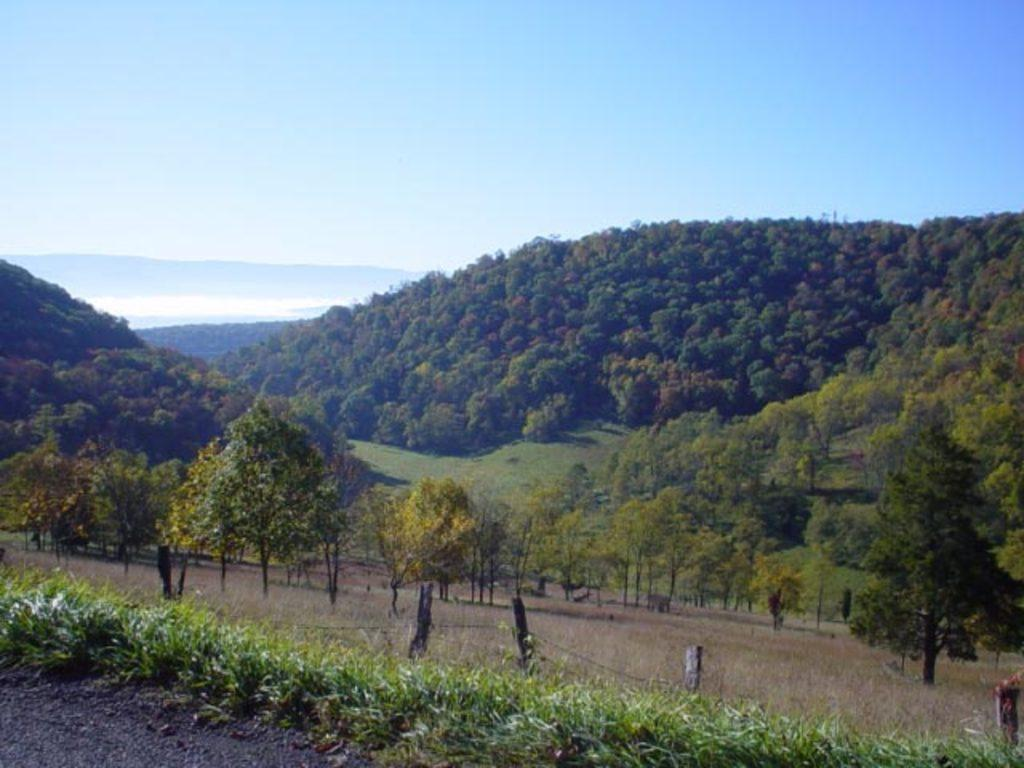What type of vegetation can be seen in the image? There are trees, plants, and grass visible in the image. What type of landscape feature is present in the image? There are hills in the image. What type of barrier can be seen in the image? There is fencing in the image. What part of the natural environment is visible in the image? The sky is visible in the image. How many brothers are depicted in the image? There are no brothers present in the image; it features trees, hills, plants, grass, fencing, and the sky. 